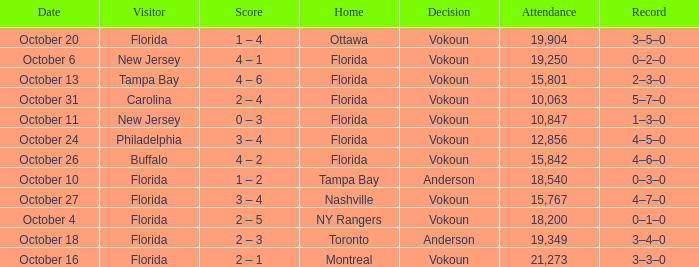What was the score on October 13? 4 – 6. 